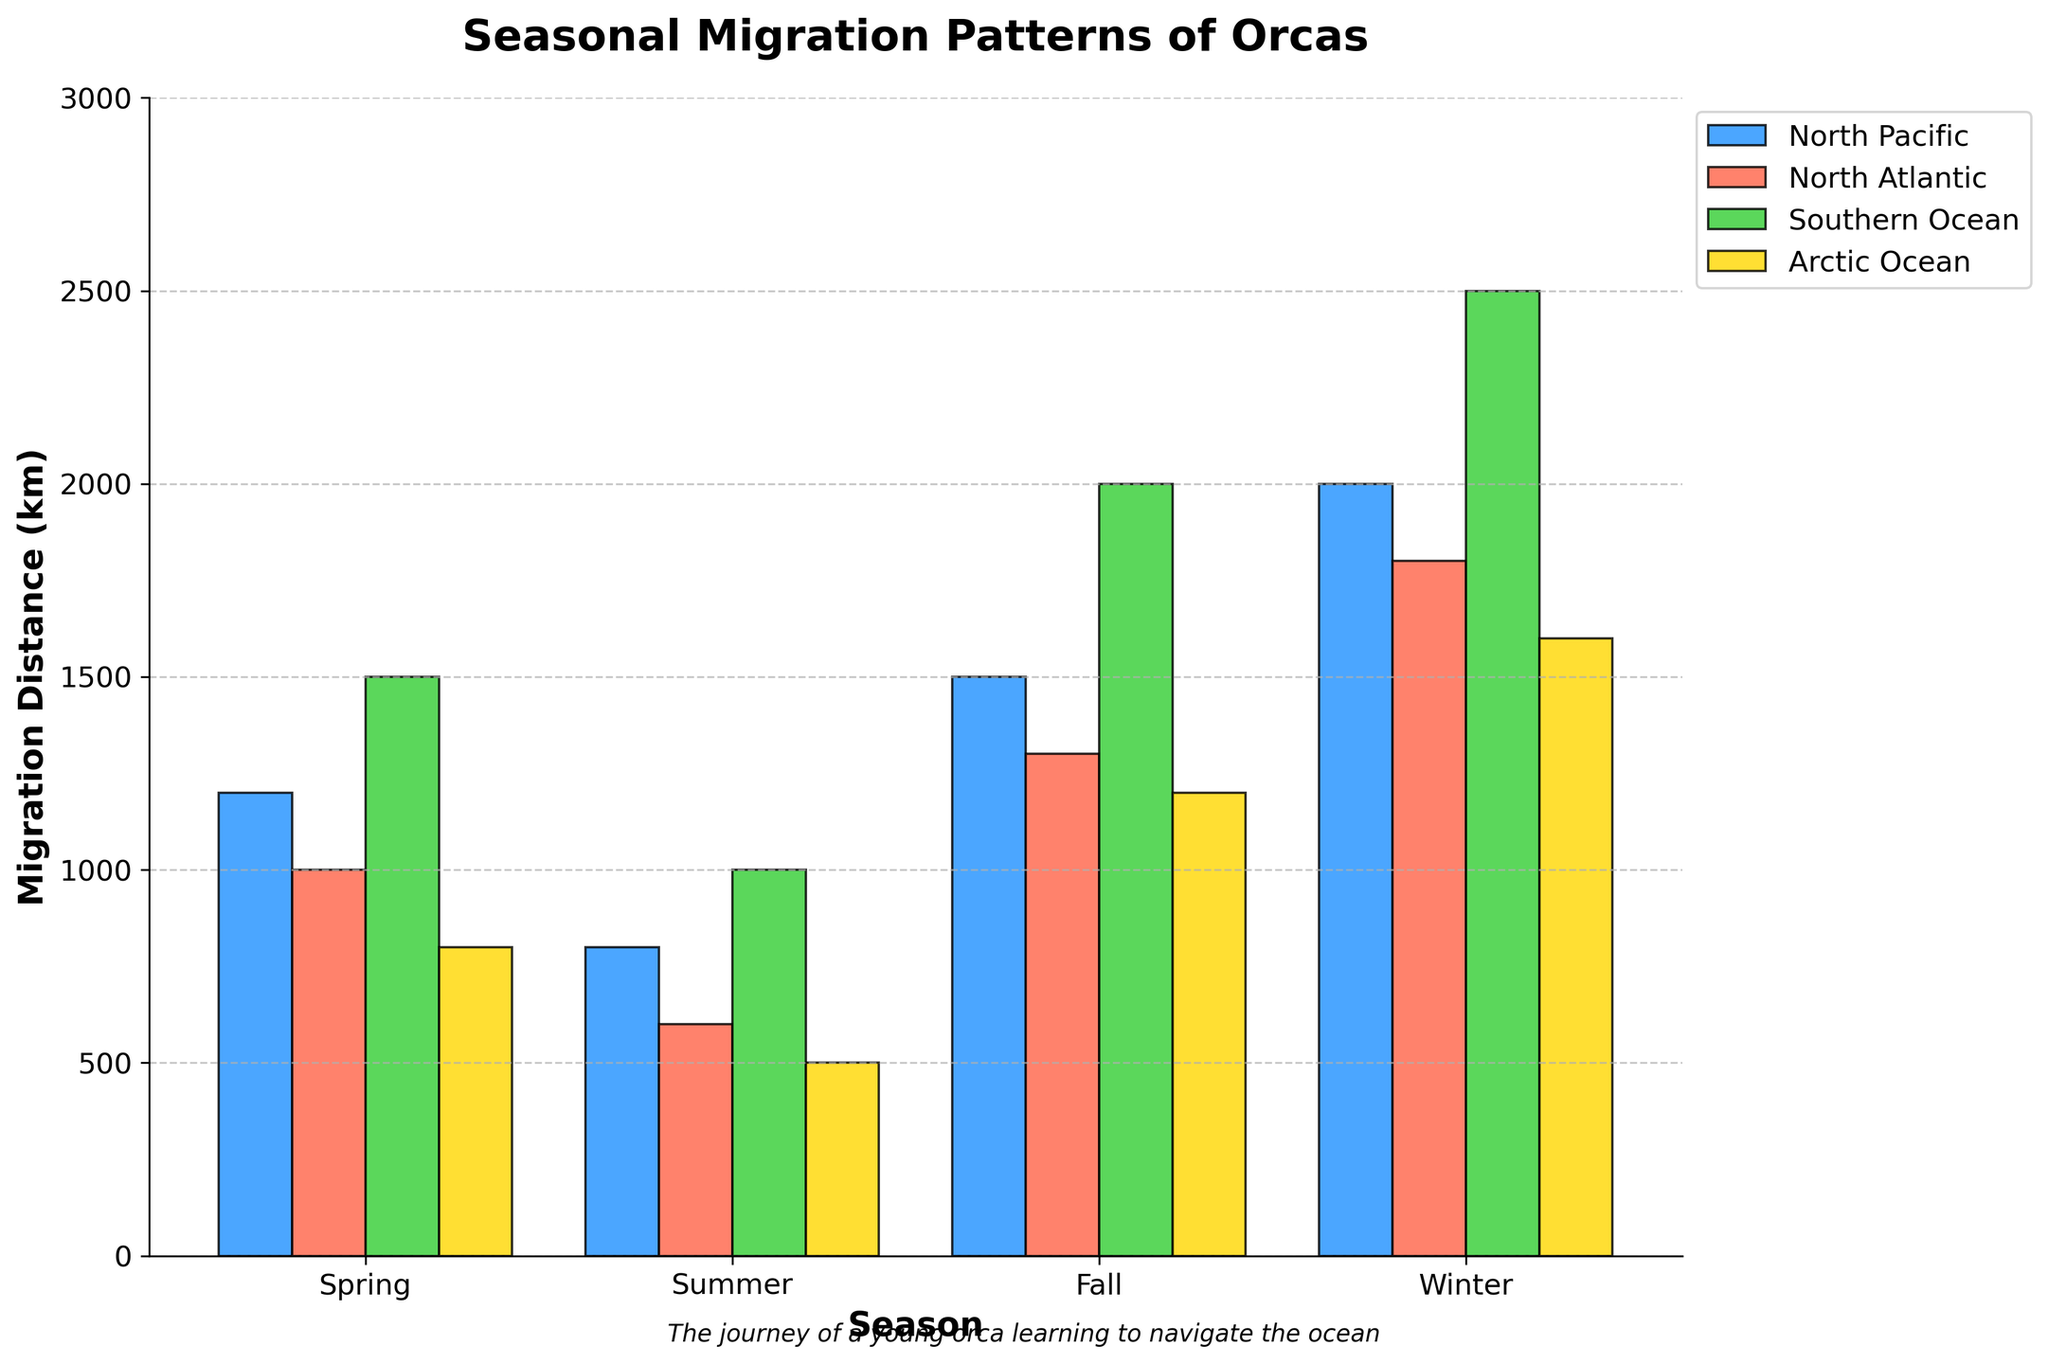Which ocean has the shortest migration distance during spring? Look at the bars for the spring season across all oceans. The Arctic Ocean has the shortest bar.
Answer: Arctic Ocean Which season shows the greatest variety in migration distances across the different oceans? Compare the height differences between the bars for all seasons. The winter season shows the widest variation in bar heights.
Answer: Winter How much longer is the migration distance in winter compared to fall for the Southern Ocean? Compare the bars for the Southern Ocean in winter and fall. Subtract the fall distance (2000 km) from the winter distance (2500 km): 2500 - 2000.
Answer: 500 km Which season has the longest migration distance for the North Pacific Ocean? Look for the tallest bar among all seasons for the North Pacific Ocean. The winter bar is the tallest.
Answer: Winter Compare the migration distances in summer between the North Atlantic and the Arctic Ocean. Which is longer? Compare the summer bars for both oceans. The North Atlantic summer bar (600 km) is longer than the Arctic Ocean summer bar (500 km).
Answer: North Atlantic What is the average migration distance in the North Atlantic Ocean across all seasons? Add the distances for all four seasons in the North Atlantic (1000 + 600 + 1300 + 1800), and divide by 4. (1000 + 600 + 1300 + 1800 = 4700; 4700 / 4 = 1175)
Answer: 1175 km Is the migration distance in the Southern Ocean in spring greater than the migration distance in the North Pacific in summer? Compare the bars for spring in the Southern Ocean (1500 km) and for summer in the North Pacific (800 km). 1500 km in the Southern Ocean is greater than 800 km in the North Pacific.
Answer: Yes For which ocean is the migration pattern the most consistent across all seasons? Compare the differences in bar heights across all seasons. The Arctic Ocean shows the most consistent migration distances with smaller differences between seasons.
Answer: Arctic Ocean 